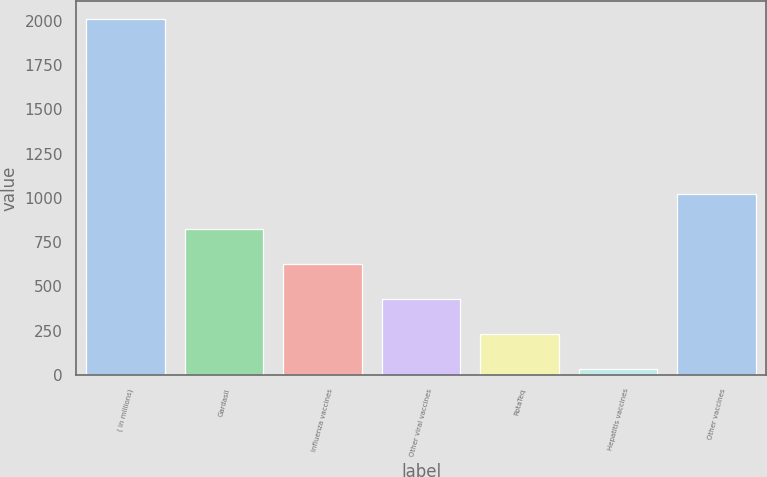<chart> <loc_0><loc_0><loc_500><loc_500><bar_chart><fcel>( in millions)<fcel>Gardasil<fcel>Influenza vaccines<fcel>Other viral vaccines<fcel>RotaTeq<fcel>Hepatitis vaccines<fcel>Other vaccines<nl><fcel>2012<fcel>823.4<fcel>625.3<fcel>427.2<fcel>229.1<fcel>31<fcel>1021.5<nl></chart> 